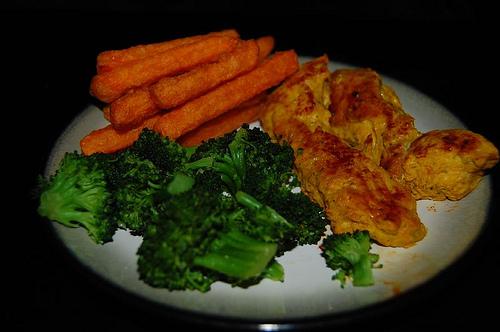Are the vegetables on a plate?
Answer briefly. Yes. What is green color?
Write a very short answer. Broccoli. How would a food critic judge this meal?
Short answer required. Good. What kind of food is shown?
Quick response, please. Healthy. What is the green stuff on the plate?
Write a very short answer. Broccoli. 